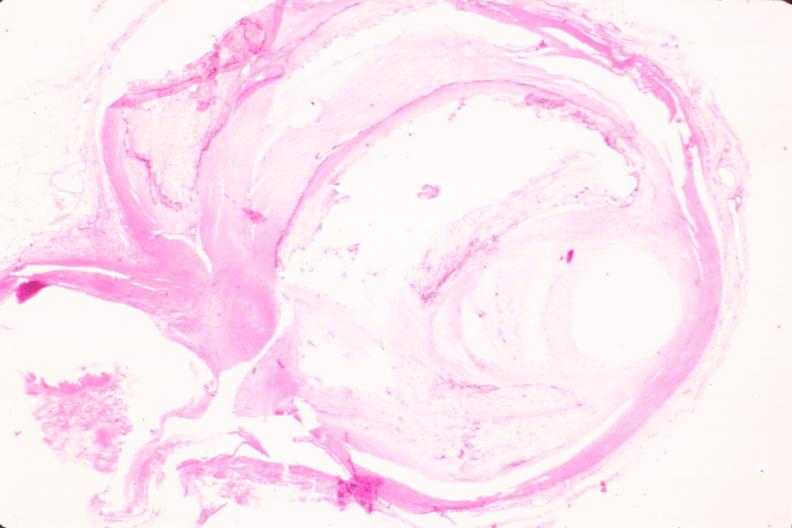s leiomyosarcoma present?
Answer the question using a single word or phrase. No 